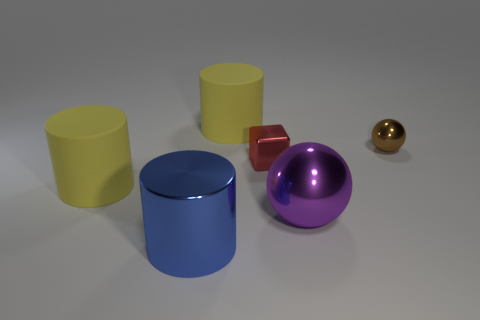Subtract all cyan spheres. How many yellow cylinders are left? 2 Add 1 tiny things. How many objects exist? 7 Subtract all big matte cylinders. How many cylinders are left? 1 Subtract all cubes. How many objects are left? 5 Subtract all green cylinders. Subtract all red cubes. How many cylinders are left? 3 Subtract all matte cylinders. Subtract all small brown balls. How many objects are left? 3 Add 5 shiny things. How many shiny things are left? 9 Add 4 tiny yellow rubber balls. How many tiny yellow rubber balls exist? 4 Subtract 0 green balls. How many objects are left? 6 